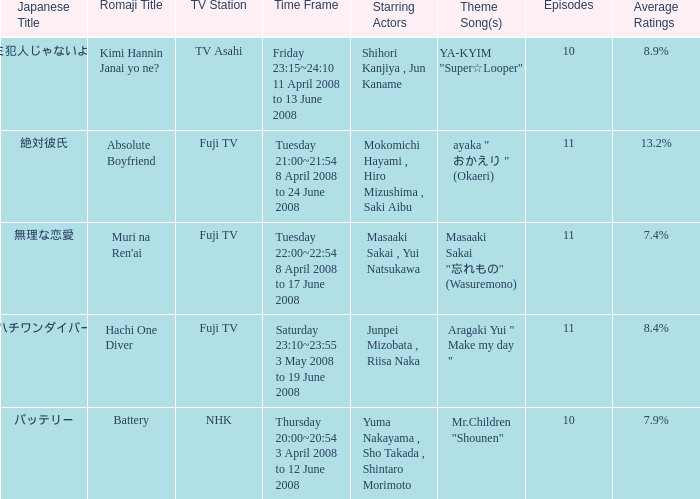What are the japanese title(s) for tv asahi? キミ犯人じゃないよね?. 